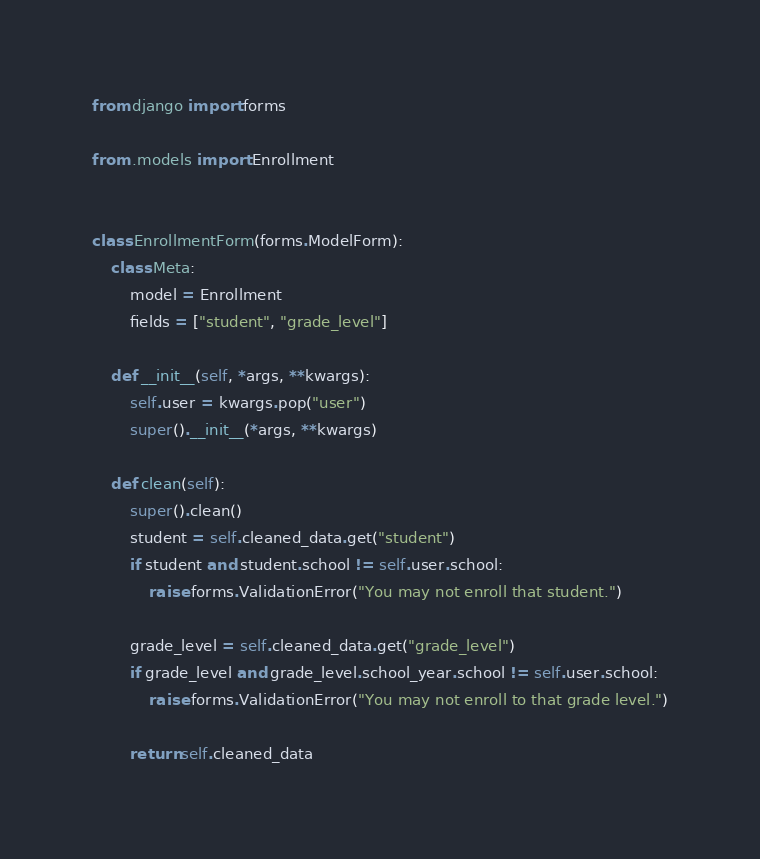<code> <loc_0><loc_0><loc_500><loc_500><_Python_>from django import forms

from .models import Enrollment


class EnrollmentForm(forms.ModelForm):
    class Meta:
        model = Enrollment
        fields = ["student", "grade_level"]

    def __init__(self, *args, **kwargs):
        self.user = kwargs.pop("user")
        super().__init__(*args, **kwargs)

    def clean(self):
        super().clean()
        student = self.cleaned_data.get("student")
        if student and student.school != self.user.school:
            raise forms.ValidationError("You may not enroll that student.")

        grade_level = self.cleaned_data.get("grade_level")
        if grade_level and grade_level.school_year.school != self.user.school:
            raise forms.ValidationError("You may not enroll to that grade level.")

        return self.cleaned_data
</code> 